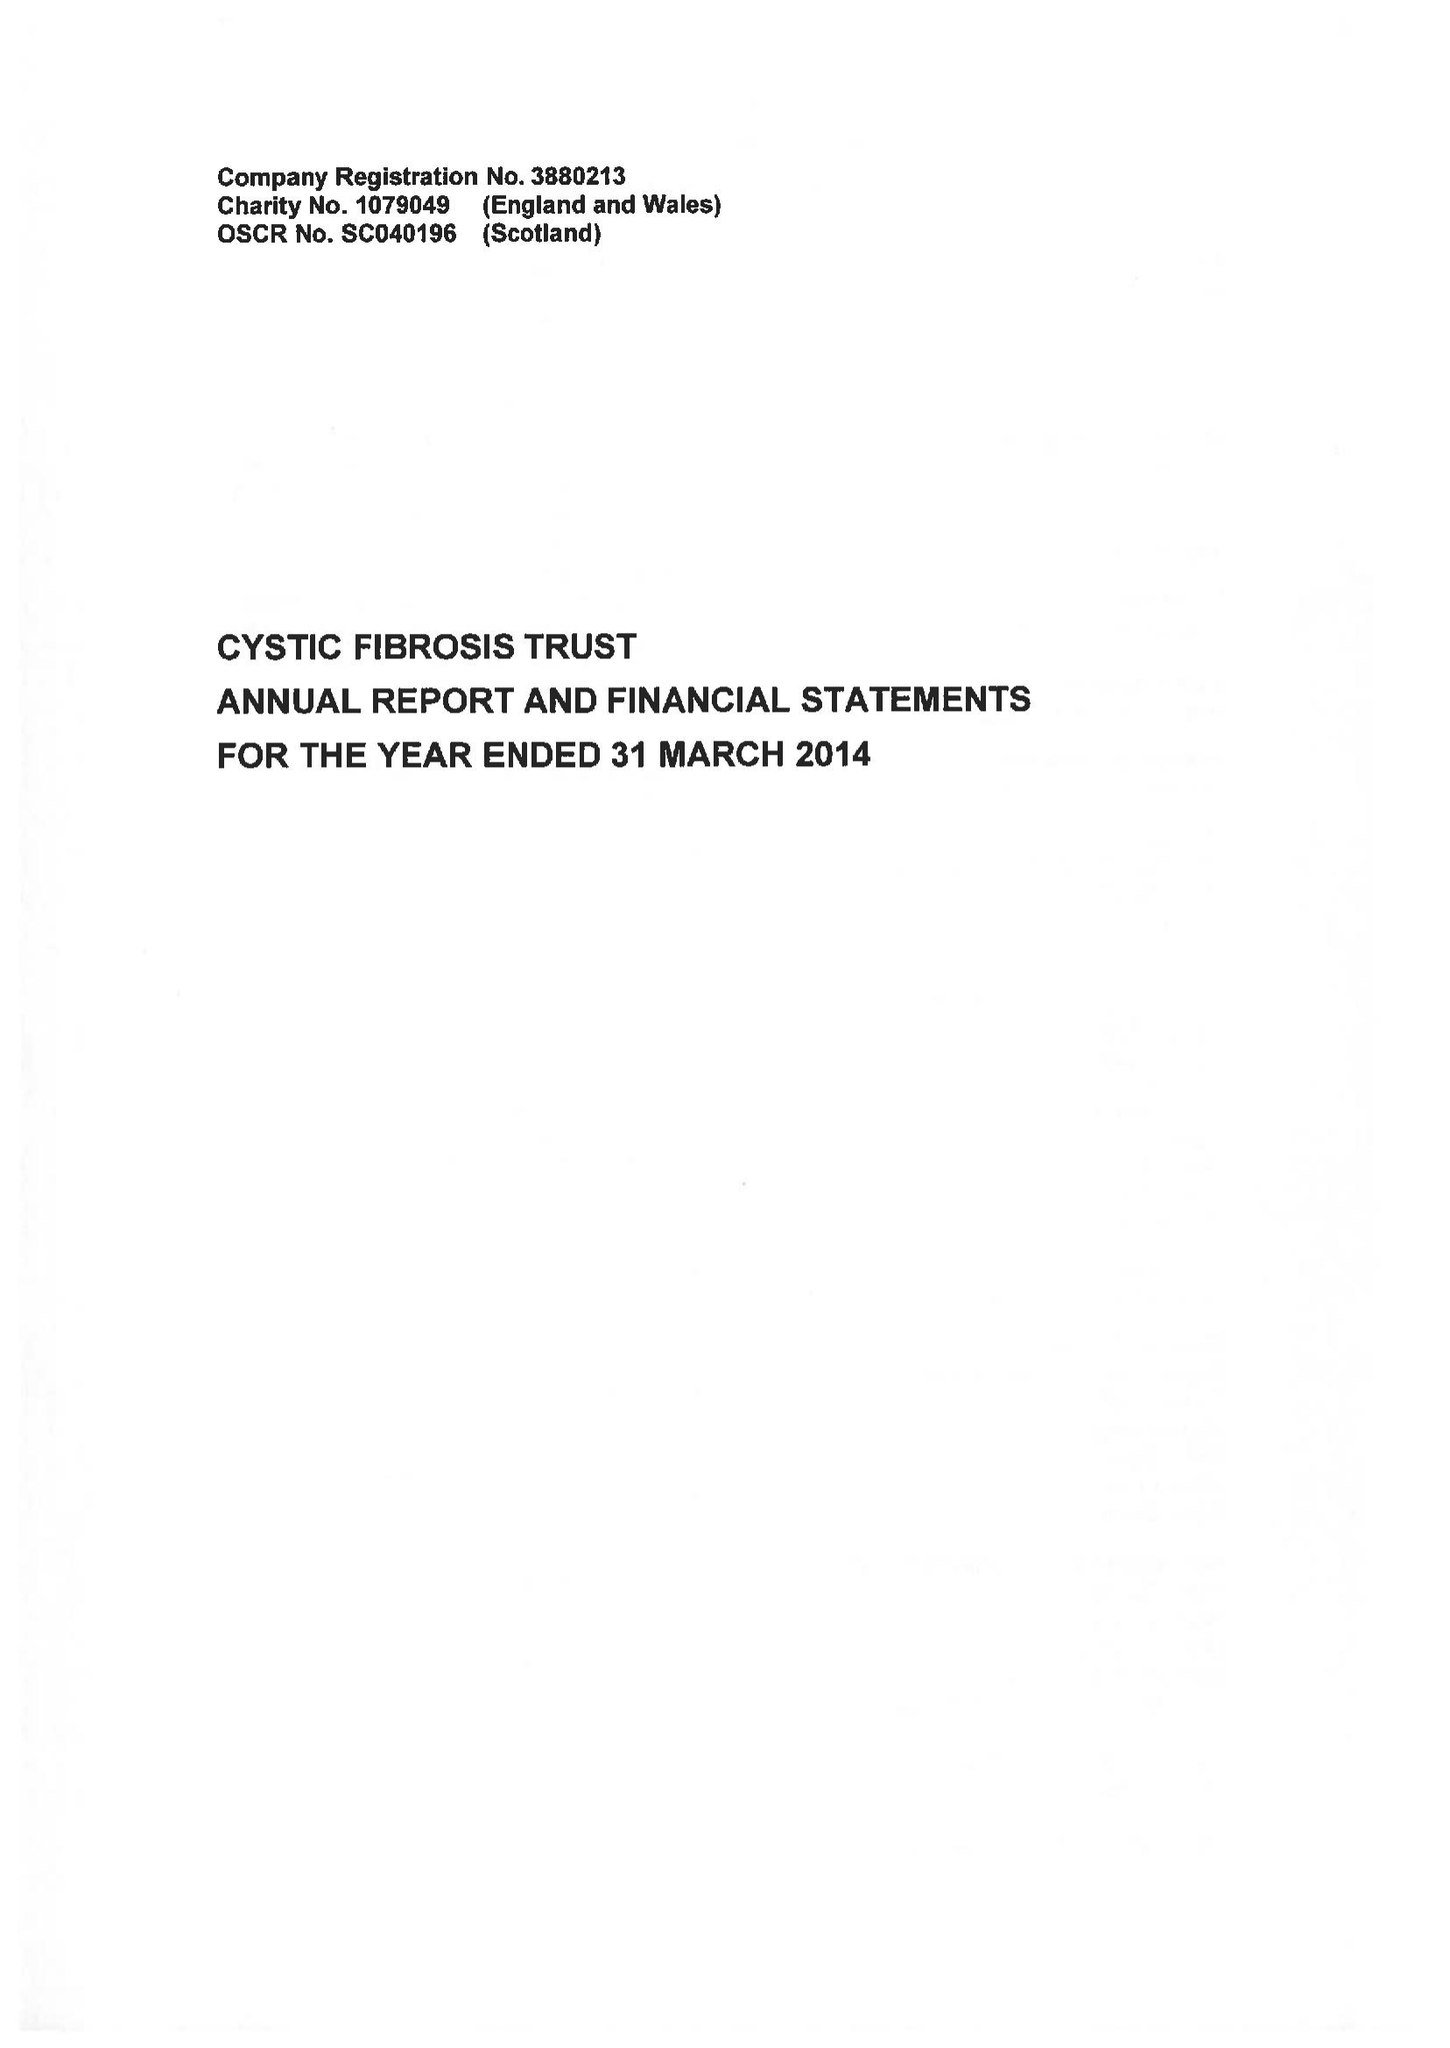What is the value for the income_annually_in_british_pounds?
Answer the question using a single word or phrase. 10806000.00 